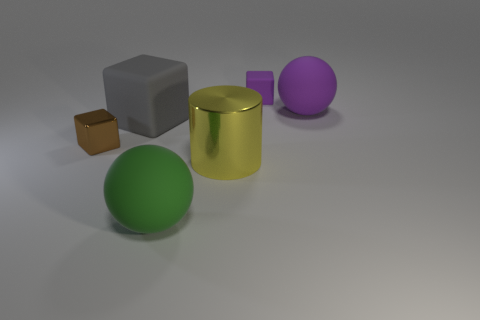Subtract all gray balls. Subtract all cyan cylinders. How many balls are left? 2 Add 2 tiny red metal spheres. How many objects exist? 8 Subtract all spheres. How many objects are left? 4 Add 1 purple matte objects. How many purple matte objects exist? 3 Subtract 0 green cylinders. How many objects are left? 6 Subtract all large matte objects. Subtract all tiny matte things. How many objects are left? 2 Add 5 large blocks. How many large blocks are left? 6 